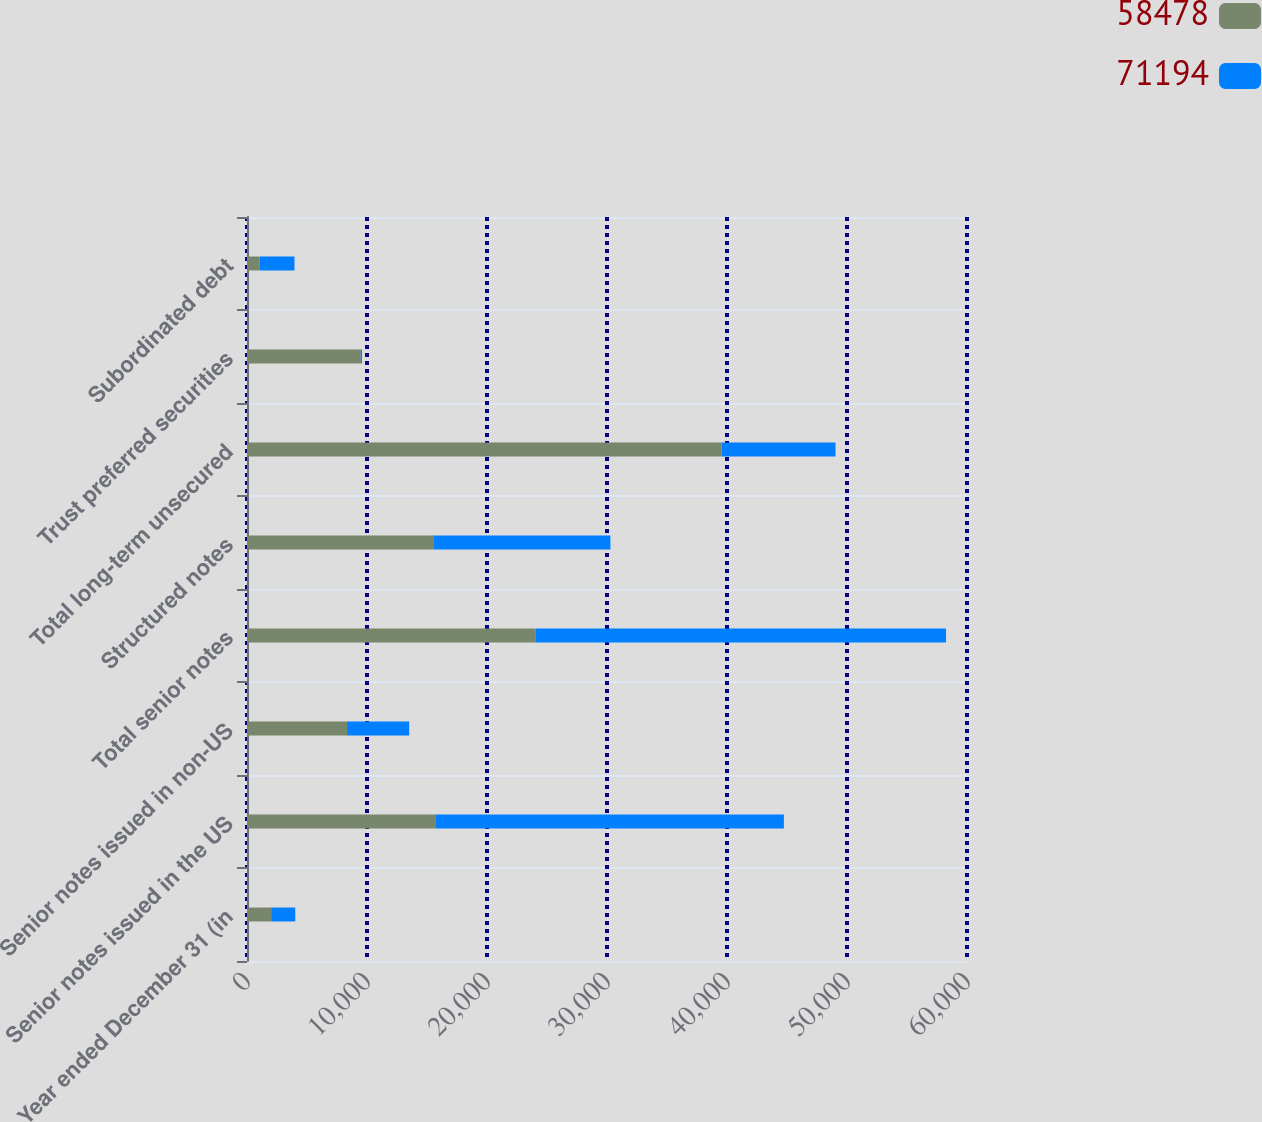Convert chart to OTSL. <chart><loc_0><loc_0><loc_500><loc_500><stacked_bar_chart><ecel><fcel>Year ended December 31 (in<fcel>Senior notes issued in the US<fcel>Senior notes issued in non-US<fcel>Total senior notes<fcel>Structured notes<fcel>Total long-term unsecured<fcel>Trust preferred securities<fcel>Subordinated debt<nl><fcel>58478<fcel>2012<fcel>15695<fcel>8341<fcel>24036<fcel>15525<fcel>39561<fcel>9482<fcel>1045<nl><fcel>71194<fcel>2011<fcel>29043<fcel>5173<fcel>34216<fcel>14761<fcel>9482<fcel>101<fcel>2912<nl></chart> 